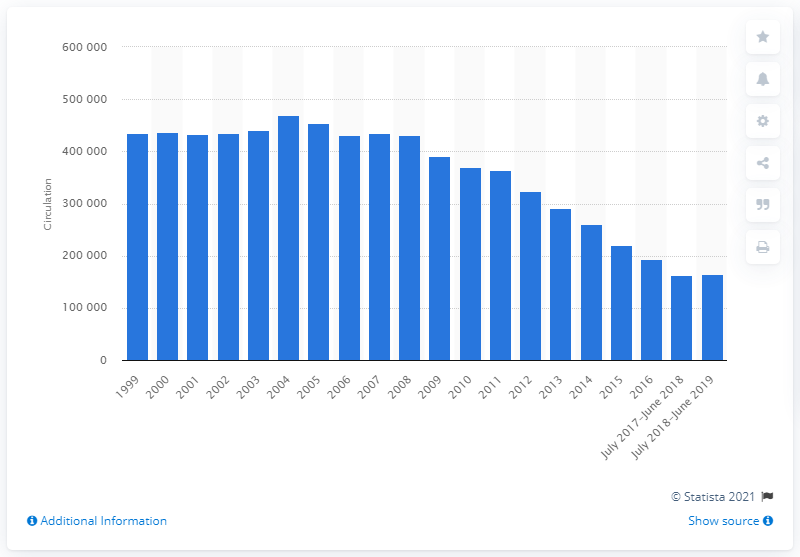Highlight a few significant elements in this photo. During the period of July 2018 and June 2019, the average print circulation of El País was 164,804. 